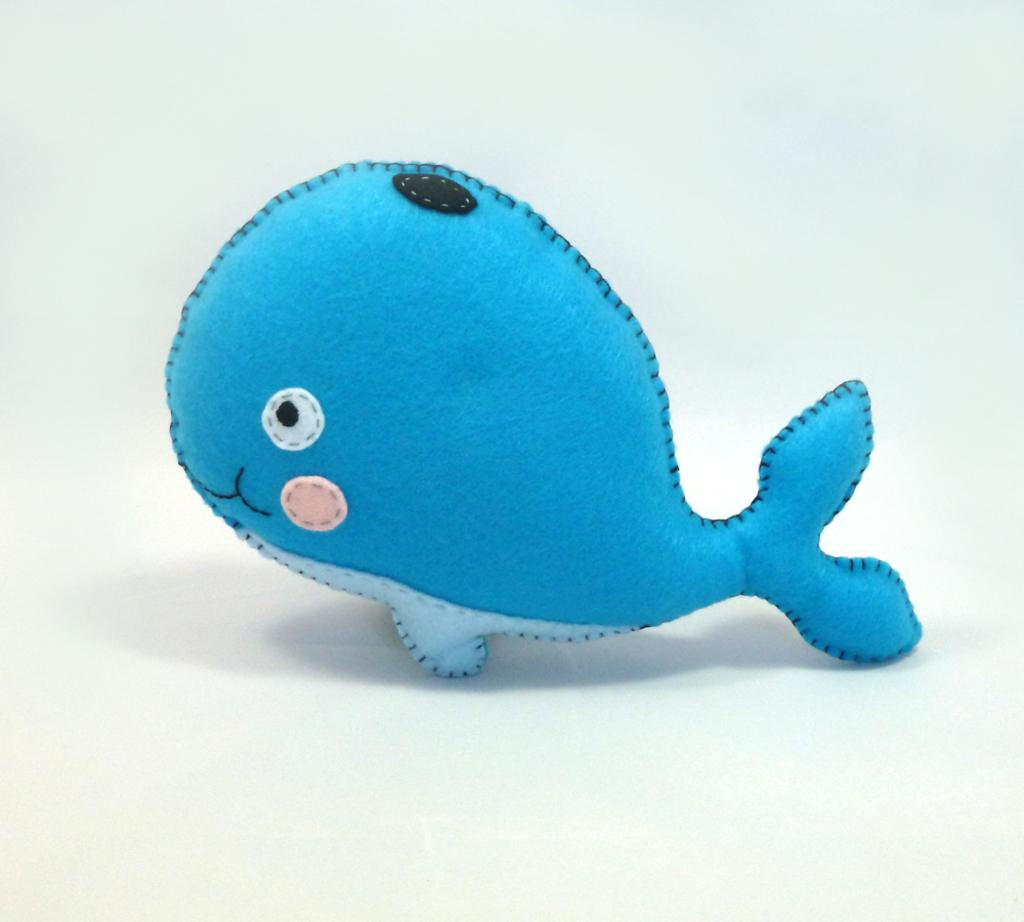What type of object is in the image? The image contains a toy. What is the shape of the toy? The toy is in the shape of a fish. What color is the toy? The toy is blue in color. What type of finger can be seen in the image? There is no finger present in the image. What type of drug can be seen in the image? There is no drug present in the image. What type of card is visible in the image? There is no card present in the image. 